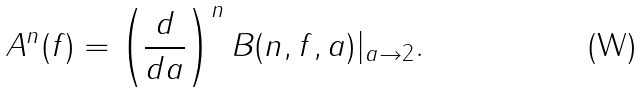<formula> <loc_0><loc_0><loc_500><loc_500>A ^ { n } ( f ) = \left ( \frac { d } { d a } \right ) ^ { n } B ( n , f , a ) | _ { a \to 2 } .</formula> 